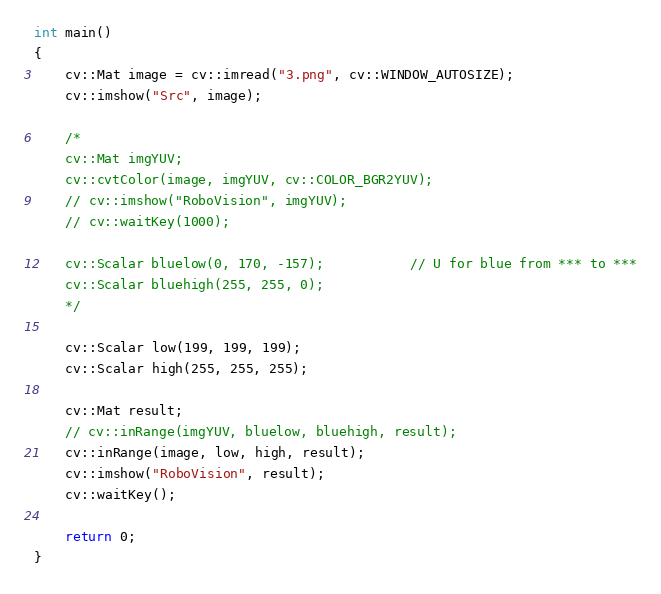Convert code to text. <code><loc_0><loc_0><loc_500><loc_500><_C++_>int main()
{
	cv::Mat image = cv::imread("3.png", cv::WINDOW_AUTOSIZE);
	cv::imshow("Src", image);

	/*
	cv::Mat imgYUV;
	cv::cvtColor(image, imgYUV, cv::COLOR_BGR2YUV);
	// cv::imshow("RoboVision", imgYUV);
	// cv::waitKey(1000);

	cv::Scalar bluelow(0, 170, -157);			// U for blue from *** to ***
	cv::Scalar bluehigh(255, 255, 0);
	*/

	cv::Scalar low(199, 199, 199);
	cv::Scalar high(255, 255, 255);
	
	cv::Mat result;
	// cv::inRange(imgYUV, bluelow, bluehigh, result);
	cv::inRange(image, low, high, result);
	cv::imshow("RoboVision", result);
	cv::waitKey();

	return 0;
}</code> 